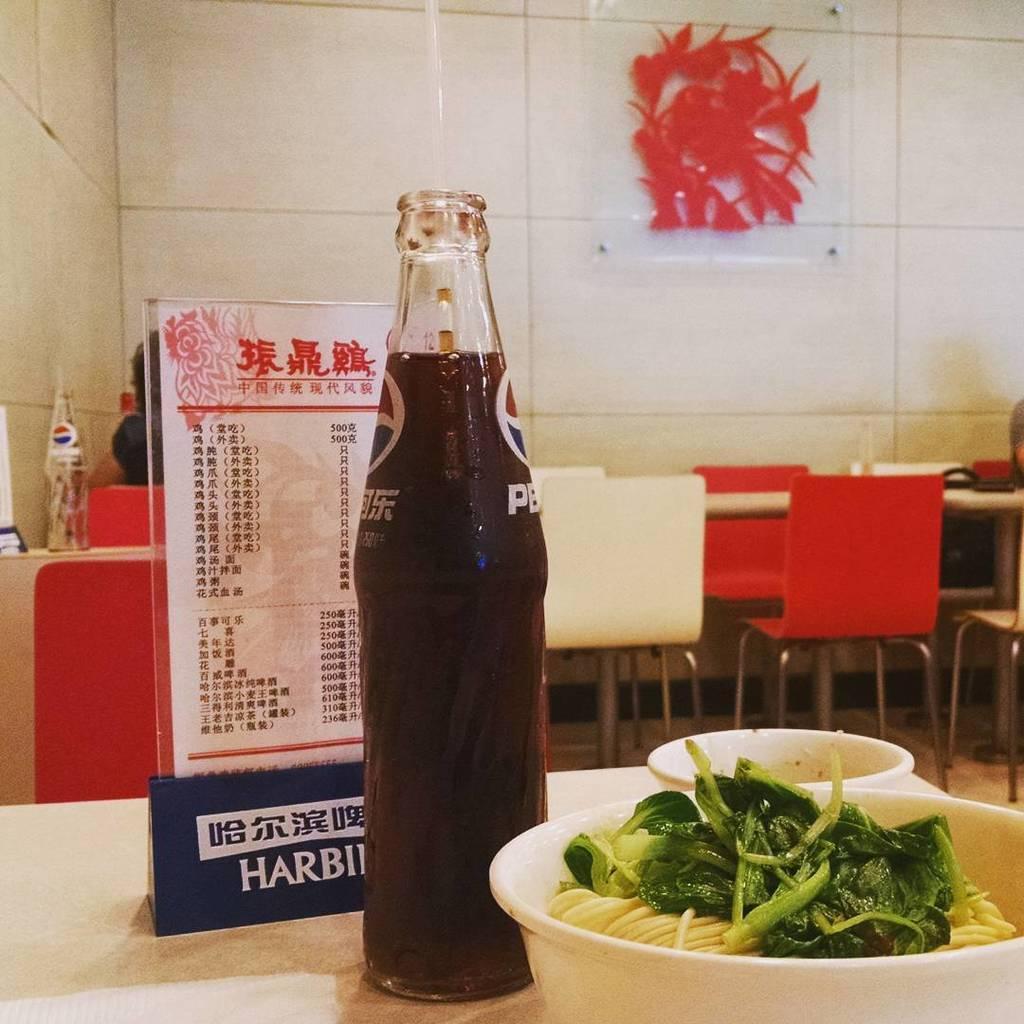In one or two sentences, can you explain what this image depicts? In this picture, it looks like a table and on the table there is a bottle, bowls and a menu card. In the bowl there is a food item. Behind the menu car there are chairs, tables and there is a glass bottle on the table. Behind the chairs there's a wall with a transparent material with a design. 